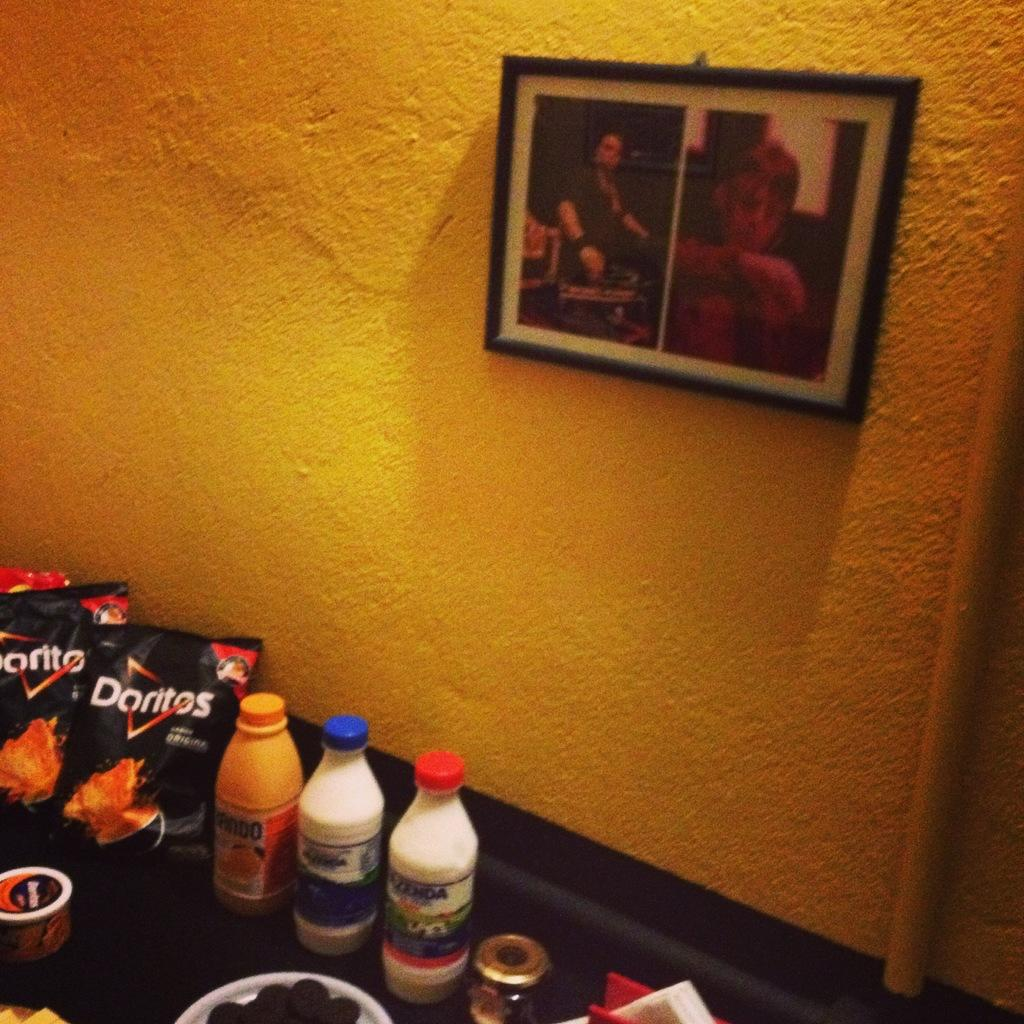<image>
Render a clear and concise summary of the photo. Bags of Doritos are on a table with drinks. 